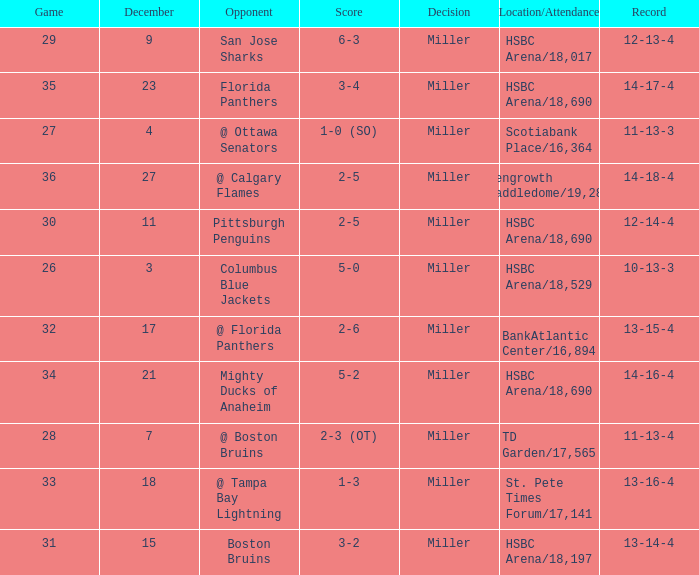Name the score for 29 game 6-3. 